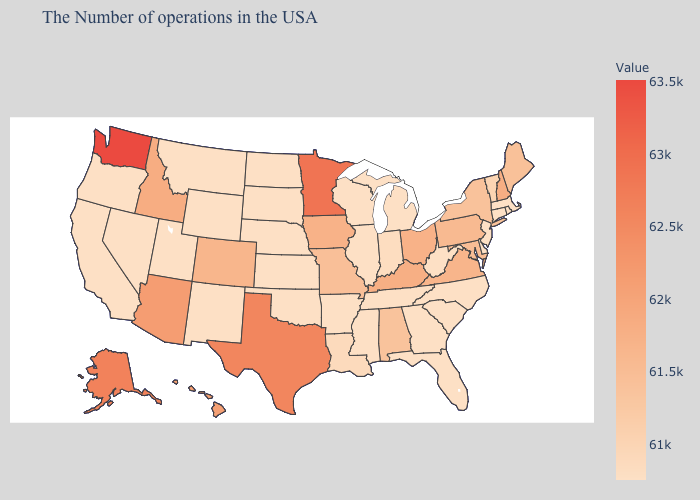Does New Jersey have the lowest value in the Northeast?
Give a very brief answer. Yes. Which states hav the highest value in the South?
Answer briefly. Texas. Is the legend a continuous bar?
Keep it brief. Yes. Which states have the lowest value in the USA?
Short answer required. Massachusetts, Rhode Island, Connecticut, New Jersey, Delaware, North Carolina, South Carolina, West Virginia, Florida, Georgia, Michigan, Tennessee, Wisconsin, Illinois, Mississippi, Arkansas, Kansas, Nebraska, Oklahoma, South Dakota, North Dakota, Wyoming, New Mexico, Utah, Montana, Nevada, California, Oregon. 